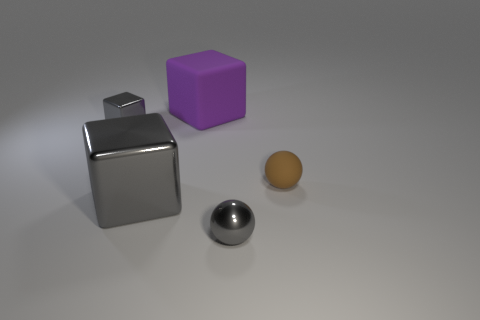What size is the gray ball?
Your response must be concise. Small. There is a large block that is behind the gray metallic block that is to the right of the gray metal object behind the brown sphere; what color is it?
Your answer should be compact. Purple. There is a shiny thing behind the small rubber thing; does it have the same color as the large shiny object?
Give a very brief answer. Yes. How many gray things are both on the right side of the purple matte thing and left of the big purple matte cube?
Keep it short and to the point. 0. The other shiny object that is the same shape as the brown object is what size?
Offer a terse response. Small. How many gray metal things are to the left of the sphere that is behind the gray object that is on the right side of the big purple block?
Make the answer very short. 3. The tiny shiny thing in front of the tiny matte object behind the gray ball is what color?
Your response must be concise. Gray. How many other objects are the same material as the purple object?
Offer a terse response. 1. There is a metal cube behind the brown rubber ball; how many blocks are behind it?
Ensure brevity in your answer.  1. Are there any other things that are the same shape as the tiny brown matte object?
Provide a succinct answer. Yes. 